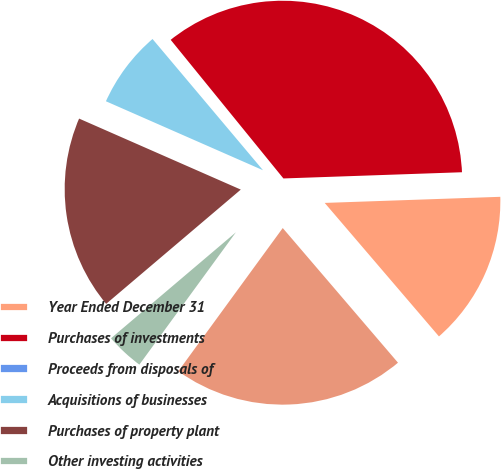Convert chart. <chart><loc_0><loc_0><loc_500><loc_500><pie_chart><fcel>Year Ended December 31<fcel>Purchases of investments<fcel>Proceeds from disposals of<fcel>Acquisitions of businesses<fcel>Purchases of property plant<fcel>Other investing activities<fcel>Net cash provided by (used in)<nl><fcel>14.29%<fcel>35.32%<fcel>0.27%<fcel>7.28%<fcel>17.79%<fcel>3.77%<fcel>21.3%<nl></chart> 